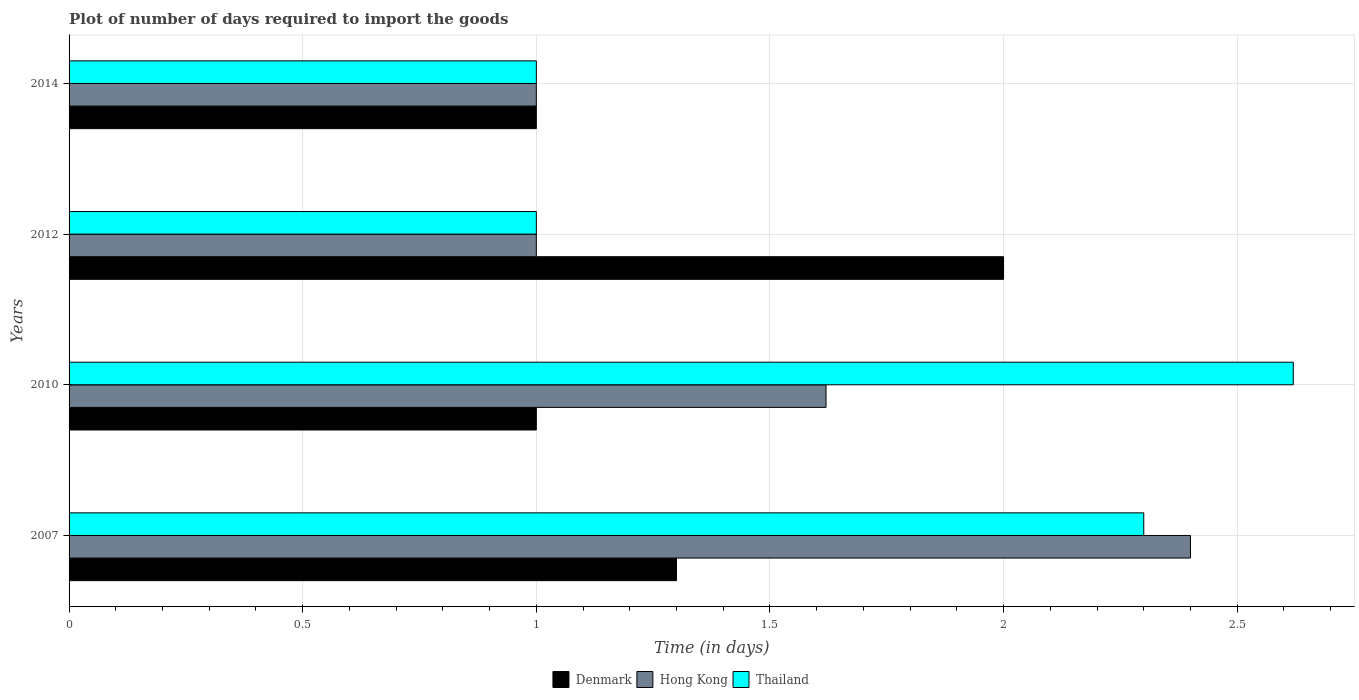How many bars are there on the 4th tick from the top?
Your response must be concise. 3. Across all years, what is the maximum time required to import goods in Denmark?
Keep it short and to the point. 2. Across all years, what is the minimum time required to import goods in Thailand?
Provide a succinct answer. 1. In which year was the time required to import goods in Hong Kong maximum?
Give a very brief answer. 2007. What is the difference between the time required to import goods in Denmark in 2007 and that in 2014?
Provide a short and direct response. 0.3. What is the difference between the time required to import goods in Hong Kong in 2007 and the time required to import goods in Denmark in 2012?
Offer a terse response. 0.4. What is the average time required to import goods in Hong Kong per year?
Offer a very short reply. 1.5. Is the time required to import goods in Thailand in 2010 less than that in 2014?
Make the answer very short. No. Is the difference between the time required to import goods in Hong Kong in 2007 and 2010 greater than the difference between the time required to import goods in Thailand in 2007 and 2010?
Offer a terse response. Yes. What is the difference between the highest and the second highest time required to import goods in Hong Kong?
Your answer should be very brief. 0.78. What is the difference between the highest and the lowest time required to import goods in Thailand?
Give a very brief answer. 1.62. In how many years, is the time required to import goods in Denmark greater than the average time required to import goods in Denmark taken over all years?
Provide a short and direct response. 1. What does the 1st bar from the top in 2010 represents?
Give a very brief answer. Thailand. Is it the case that in every year, the sum of the time required to import goods in Denmark and time required to import goods in Thailand is greater than the time required to import goods in Hong Kong?
Give a very brief answer. Yes. Are all the bars in the graph horizontal?
Keep it short and to the point. Yes. How many years are there in the graph?
Your answer should be very brief. 4. What is the difference between two consecutive major ticks on the X-axis?
Provide a short and direct response. 0.5. Are the values on the major ticks of X-axis written in scientific E-notation?
Provide a succinct answer. No. Does the graph contain grids?
Your response must be concise. Yes. Where does the legend appear in the graph?
Provide a succinct answer. Bottom center. What is the title of the graph?
Make the answer very short. Plot of number of days required to import the goods. Does "Cuba" appear as one of the legend labels in the graph?
Offer a terse response. No. What is the label or title of the X-axis?
Ensure brevity in your answer.  Time (in days). What is the Time (in days) in Hong Kong in 2007?
Your response must be concise. 2.4. What is the Time (in days) in Thailand in 2007?
Keep it short and to the point. 2.3. What is the Time (in days) of Denmark in 2010?
Keep it short and to the point. 1. What is the Time (in days) of Hong Kong in 2010?
Your response must be concise. 1.62. What is the Time (in days) of Thailand in 2010?
Your answer should be very brief. 2.62. What is the Time (in days) of Thailand in 2012?
Ensure brevity in your answer.  1. Across all years, what is the maximum Time (in days) in Thailand?
Your response must be concise. 2.62. Across all years, what is the minimum Time (in days) in Denmark?
Offer a terse response. 1. What is the total Time (in days) of Denmark in the graph?
Your response must be concise. 5.3. What is the total Time (in days) of Hong Kong in the graph?
Provide a succinct answer. 6.02. What is the total Time (in days) in Thailand in the graph?
Offer a terse response. 6.92. What is the difference between the Time (in days) of Hong Kong in 2007 and that in 2010?
Ensure brevity in your answer.  0.78. What is the difference between the Time (in days) of Thailand in 2007 and that in 2010?
Your answer should be compact. -0.32. What is the difference between the Time (in days) of Hong Kong in 2007 and that in 2012?
Make the answer very short. 1.4. What is the difference between the Time (in days) in Thailand in 2007 and that in 2012?
Your response must be concise. 1.3. What is the difference between the Time (in days) in Hong Kong in 2007 and that in 2014?
Offer a very short reply. 1.4. What is the difference between the Time (in days) in Thailand in 2007 and that in 2014?
Your answer should be compact. 1.3. What is the difference between the Time (in days) of Hong Kong in 2010 and that in 2012?
Provide a short and direct response. 0.62. What is the difference between the Time (in days) in Thailand in 2010 and that in 2012?
Provide a succinct answer. 1.62. What is the difference between the Time (in days) of Hong Kong in 2010 and that in 2014?
Give a very brief answer. 0.62. What is the difference between the Time (in days) in Thailand in 2010 and that in 2014?
Provide a short and direct response. 1.62. What is the difference between the Time (in days) in Thailand in 2012 and that in 2014?
Your answer should be very brief. 0. What is the difference between the Time (in days) in Denmark in 2007 and the Time (in days) in Hong Kong in 2010?
Give a very brief answer. -0.32. What is the difference between the Time (in days) of Denmark in 2007 and the Time (in days) of Thailand in 2010?
Offer a terse response. -1.32. What is the difference between the Time (in days) of Hong Kong in 2007 and the Time (in days) of Thailand in 2010?
Give a very brief answer. -0.22. What is the difference between the Time (in days) in Denmark in 2007 and the Time (in days) in Thailand in 2012?
Offer a terse response. 0.3. What is the difference between the Time (in days) of Denmark in 2007 and the Time (in days) of Hong Kong in 2014?
Your answer should be compact. 0.3. What is the difference between the Time (in days) of Denmark in 2007 and the Time (in days) of Thailand in 2014?
Your answer should be compact. 0.3. What is the difference between the Time (in days) in Denmark in 2010 and the Time (in days) in Hong Kong in 2012?
Keep it short and to the point. 0. What is the difference between the Time (in days) of Hong Kong in 2010 and the Time (in days) of Thailand in 2012?
Keep it short and to the point. 0.62. What is the difference between the Time (in days) of Hong Kong in 2010 and the Time (in days) of Thailand in 2014?
Your answer should be very brief. 0.62. What is the difference between the Time (in days) in Hong Kong in 2012 and the Time (in days) in Thailand in 2014?
Provide a short and direct response. 0. What is the average Time (in days) in Denmark per year?
Offer a very short reply. 1.32. What is the average Time (in days) of Hong Kong per year?
Offer a very short reply. 1.5. What is the average Time (in days) of Thailand per year?
Give a very brief answer. 1.73. In the year 2007, what is the difference between the Time (in days) of Denmark and Time (in days) of Hong Kong?
Offer a very short reply. -1.1. In the year 2007, what is the difference between the Time (in days) in Denmark and Time (in days) in Thailand?
Ensure brevity in your answer.  -1. In the year 2007, what is the difference between the Time (in days) of Hong Kong and Time (in days) of Thailand?
Make the answer very short. 0.1. In the year 2010, what is the difference between the Time (in days) in Denmark and Time (in days) in Hong Kong?
Make the answer very short. -0.62. In the year 2010, what is the difference between the Time (in days) in Denmark and Time (in days) in Thailand?
Your answer should be compact. -1.62. In the year 2010, what is the difference between the Time (in days) in Hong Kong and Time (in days) in Thailand?
Your answer should be compact. -1. In the year 2012, what is the difference between the Time (in days) of Denmark and Time (in days) of Thailand?
Provide a short and direct response. 1. In the year 2014, what is the difference between the Time (in days) of Denmark and Time (in days) of Hong Kong?
Provide a short and direct response. 0. In the year 2014, what is the difference between the Time (in days) in Denmark and Time (in days) in Thailand?
Give a very brief answer. 0. What is the ratio of the Time (in days) in Hong Kong in 2007 to that in 2010?
Offer a very short reply. 1.48. What is the ratio of the Time (in days) of Thailand in 2007 to that in 2010?
Your answer should be very brief. 0.88. What is the ratio of the Time (in days) of Denmark in 2007 to that in 2012?
Make the answer very short. 0.65. What is the ratio of the Time (in days) of Hong Kong in 2007 to that in 2012?
Offer a very short reply. 2.4. What is the ratio of the Time (in days) of Hong Kong in 2007 to that in 2014?
Make the answer very short. 2.4. What is the ratio of the Time (in days) of Thailand in 2007 to that in 2014?
Give a very brief answer. 2.3. What is the ratio of the Time (in days) of Denmark in 2010 to that in 2012?
Offer a very short reply. 0.5. What is the ratio of the Time (in days) in Hong Kong in 2010 to that in 2012?
Keep it short and to the point. 1.62. What is the ratio of the Time (in days) of Thailand in 2010 to that in 2012?
Ensure brevity in your answer.  2.62. What is the ratio of the Time (in days) of Denmark in 2010 to that in 2014?
Provide a succinct answer. 1. What is the ratio of the Time (in days) of Hong Kong in 2010 to that in 2014?
Provide a succinct answer. 1.62. What is the ratio of the Time (in days) in Thailand in 2010 to that in 2014?
Give a very brief answer. 2.62. What is the ratio of the Time (in days) in Hong Kong in 2012 to that in 2014?
Your answer should be compact. 1. What is the ratio of the Time (in days) of Thailand in 2012 to that in 2014?
Give a very brief answer. 1. What is the difference between the highest and the second highest Time (in days) of Hong Kong?
Keep it short and to the point. 0.78. What is the difference between the highest and the second highest Time (in days) in Thailand?
Make the answer very short. 0.32. What is the difference between the highest and the lowest Time (in days) of Denmark?
Ensure brevity in your answer.  1. What is the difference between the highest and the lowest Time (in days) in Thailand?
Provide a short and direct response. 1.62. 